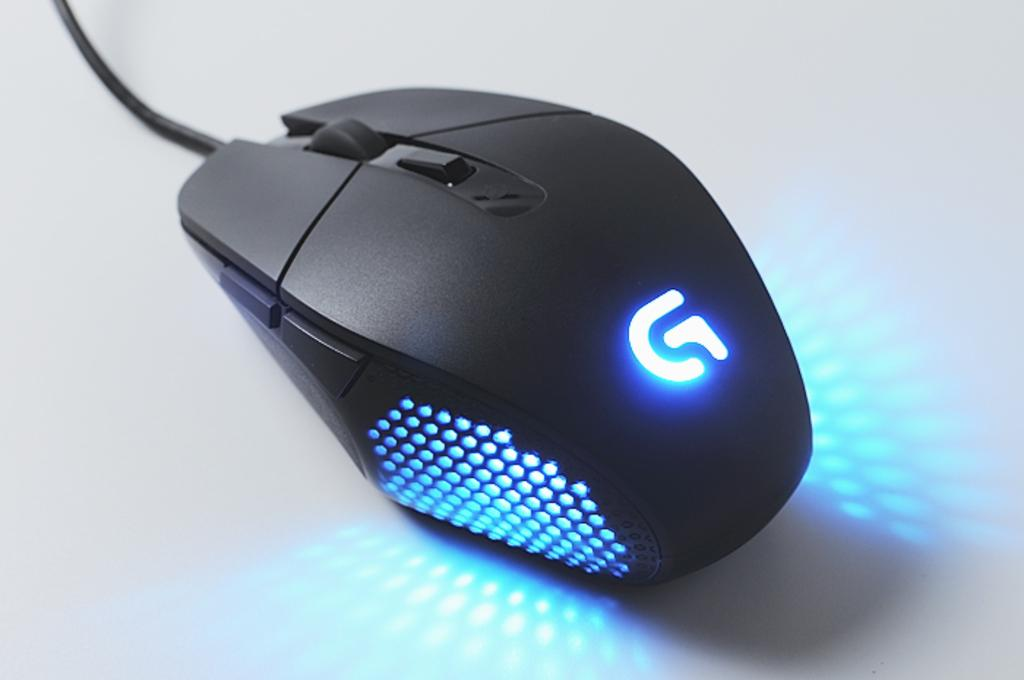Provide a one-sentence caption for the provided image. A Logitech G-series mouse is lit up with blue RGB lighting. 